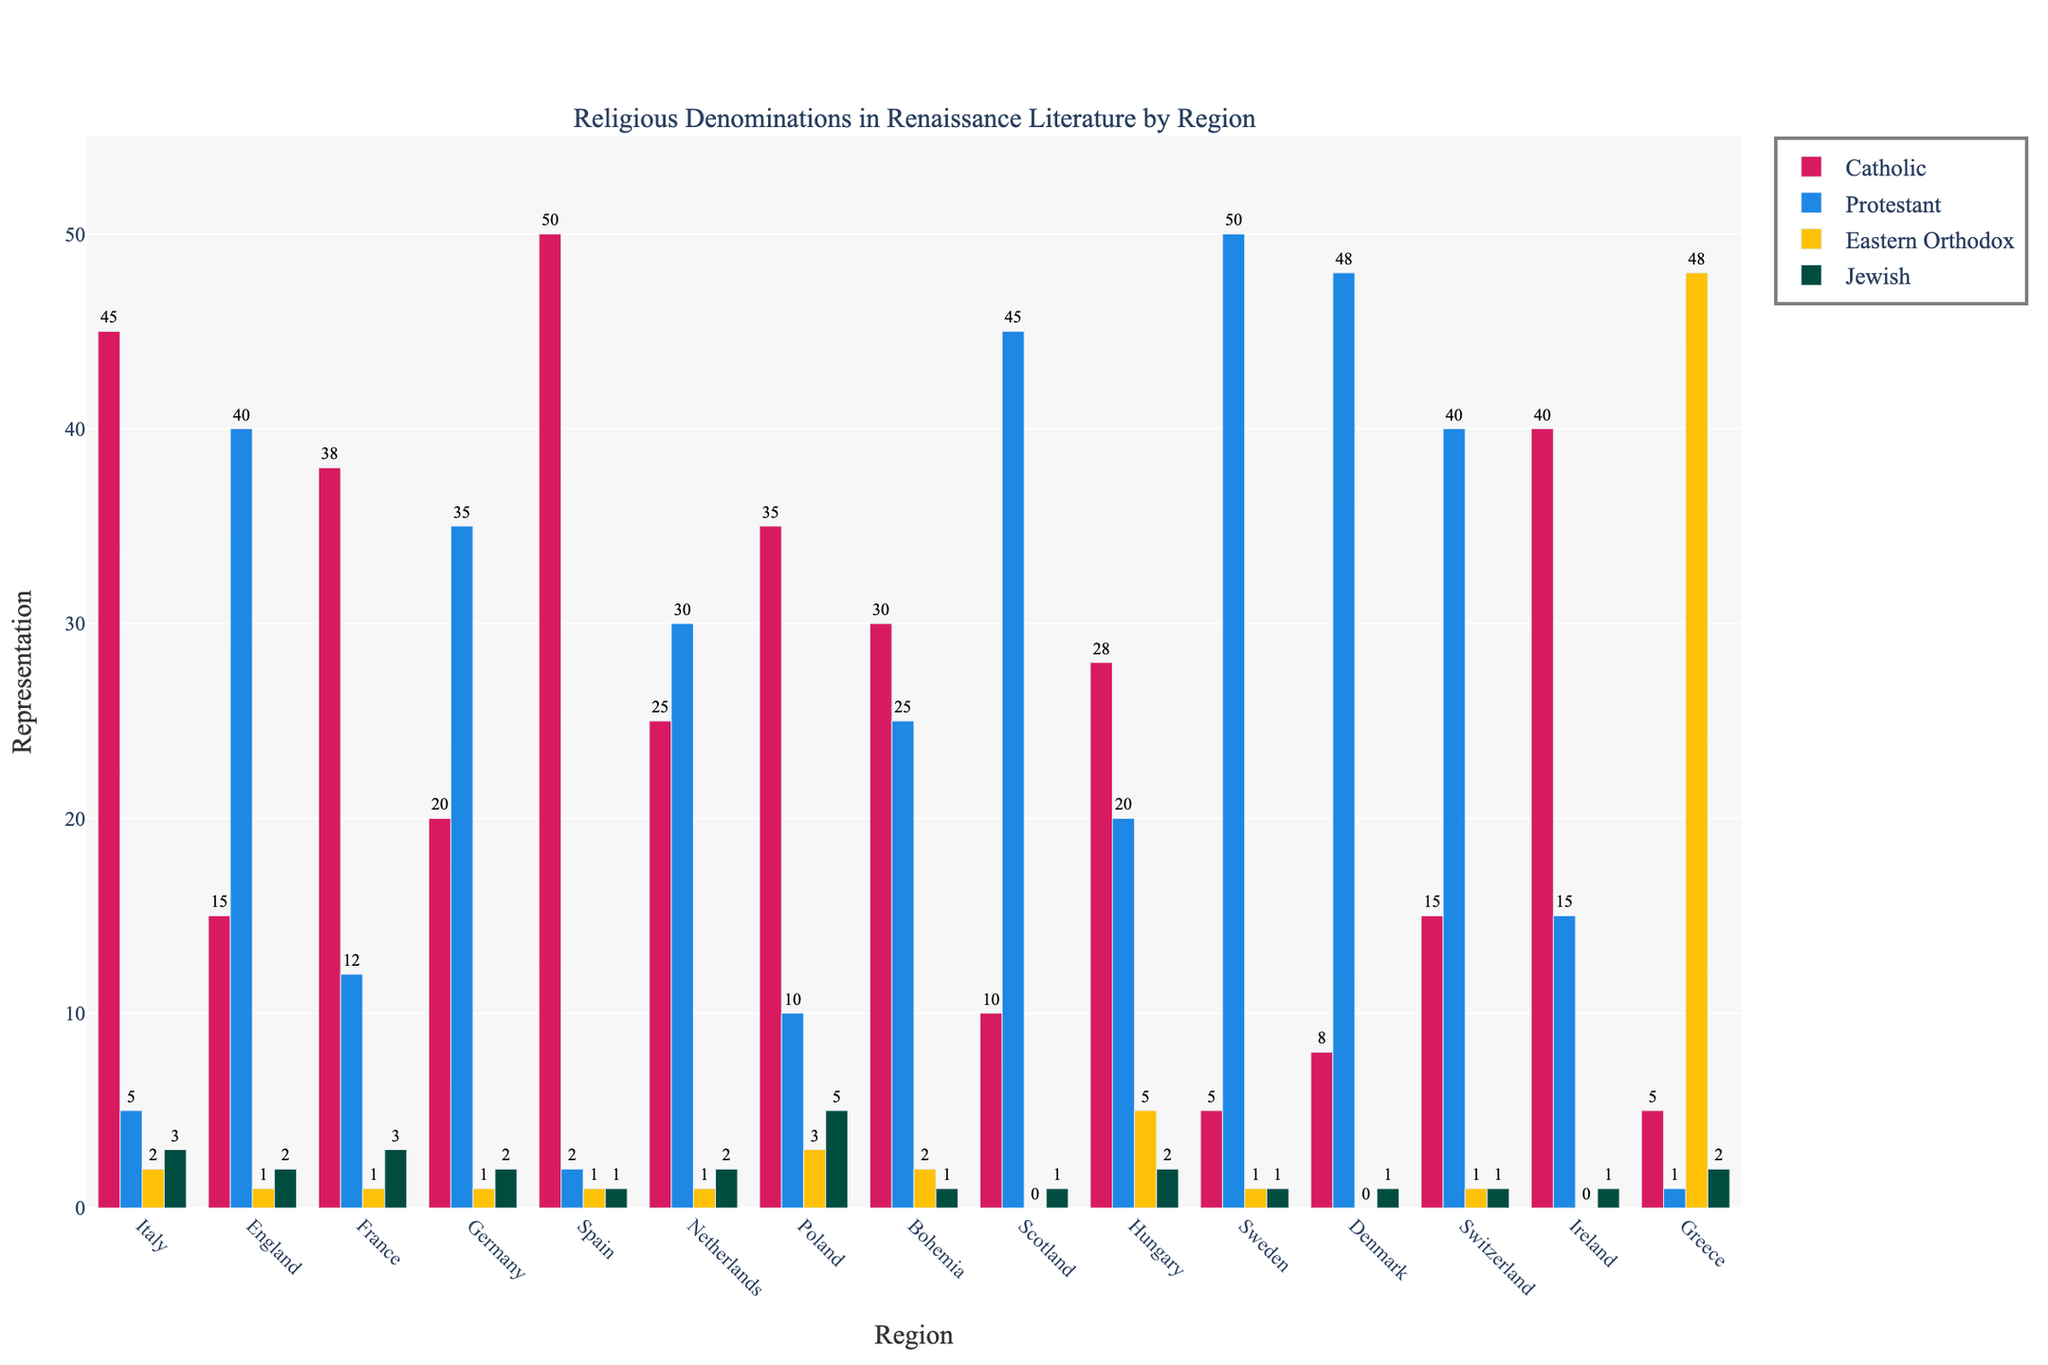Which region has the highest representation of Catholics? The tallest red bar (representing Catholics) is clearly visible in the bar corresponding to Spain.
Answer: Spain Which denomination has the highest overall representation in Sweden? The tallest bar in the Sweden category is blue, which represents Protestants.
Answer: Protestant How many more Catholics are represented in Italy compared to England? The red bar for Catholics in Italy is at 45, and in England, it is at 15. Subtract 15 from 45 to get the difference.
Answer: 30 Which region has the highest representation of the Eastern Orthodox denomination? The tallest yellow bar (representing Eastern Orthodox) is in the Greece category at a height of 48.
Answer: Greece What's the sum of Jewish representation across Italy and Poland? The heights of the green bars (representing Jewish) in Italy and Poland are 3 and 5 respectively. Add these values together: 3 + 5.
Answer: 8 Which denomination is most equally represented across the regions? By visually comparing the heights of the bars for each denomination, Catholics (red bars) have more consistent heights across different regions.
Answer: Catholic Compare the representation of Protestants in Germany and France. Which region has higher representation? The blue bar for Protestants in Germany is 35, whereas in France it is 12. Germany has the higher representation.
Answer: Germany What's the average representation of Protestants across all regions? Sum of Protestant values across all regions is 371; divide by the number of regions, 14. (15+40+12+35+2+30+10+25+45+20+50+48+40+15)/14 = 26.5
Answer: 26.5 Which region has the lowest representation of Jews? The green bars representing Jews are at the lowest height (0) in Scotland, Ireland, Denmark, and Switzerland. These regions are tied for the lowest representation.
Answer: Scotland, Ireland, Denmark, Switzerland What is the difference in representation of Catholics between Poland and Hungary? The red bar for Catholics in Poland is 35 and in Hungary is 28. Subtract 28 from 35.
Answer: 7 